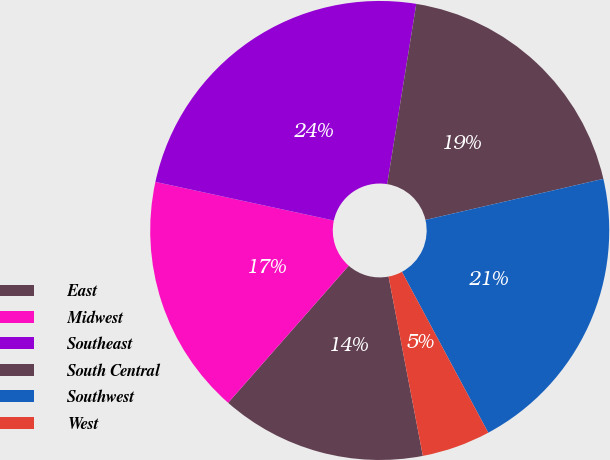Convert chart. <chart><loc_0><loc_0><loc_500><loc_500><pie_chart><fcel>East<fcel>Midwest<fcel>Southeast<fcel>South Central<fcel>Southwest<fcel>West<nl><fcel>14.49%<fcel>16.91%<fcel>24.15%<fcel>18.84%<fcel>20.77%<fcel>4.83%<nl></chart> 